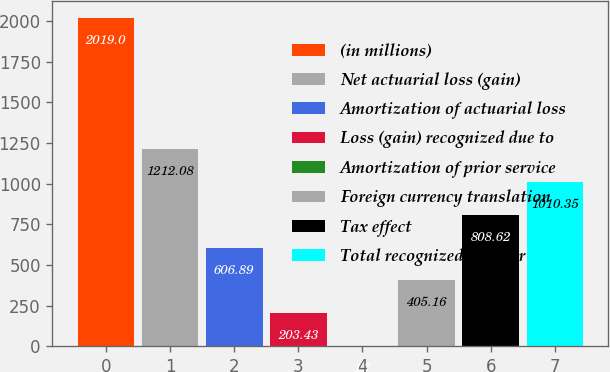Convert chart to OTSL. <chart><loc_0><loc_0><loc_500><loc_500><bar_chart><fcel>(in millions)<fcel>Net actuarial loss (gain)<fcel>Amortization of actuarial loss<fcel>Loss (gain) recognized due to<fcel>Amortization of prior service<fcel>Foreign currency translation<fcel>Tax effect<fcel>Total recognized in other<nl><fcel>2019<fcel>1212.08<fcel>606.89<fcel>203.43<fcel>1.7<fcel>405.16<fcel>808.62<fcel>1010.35<nl></chart> 